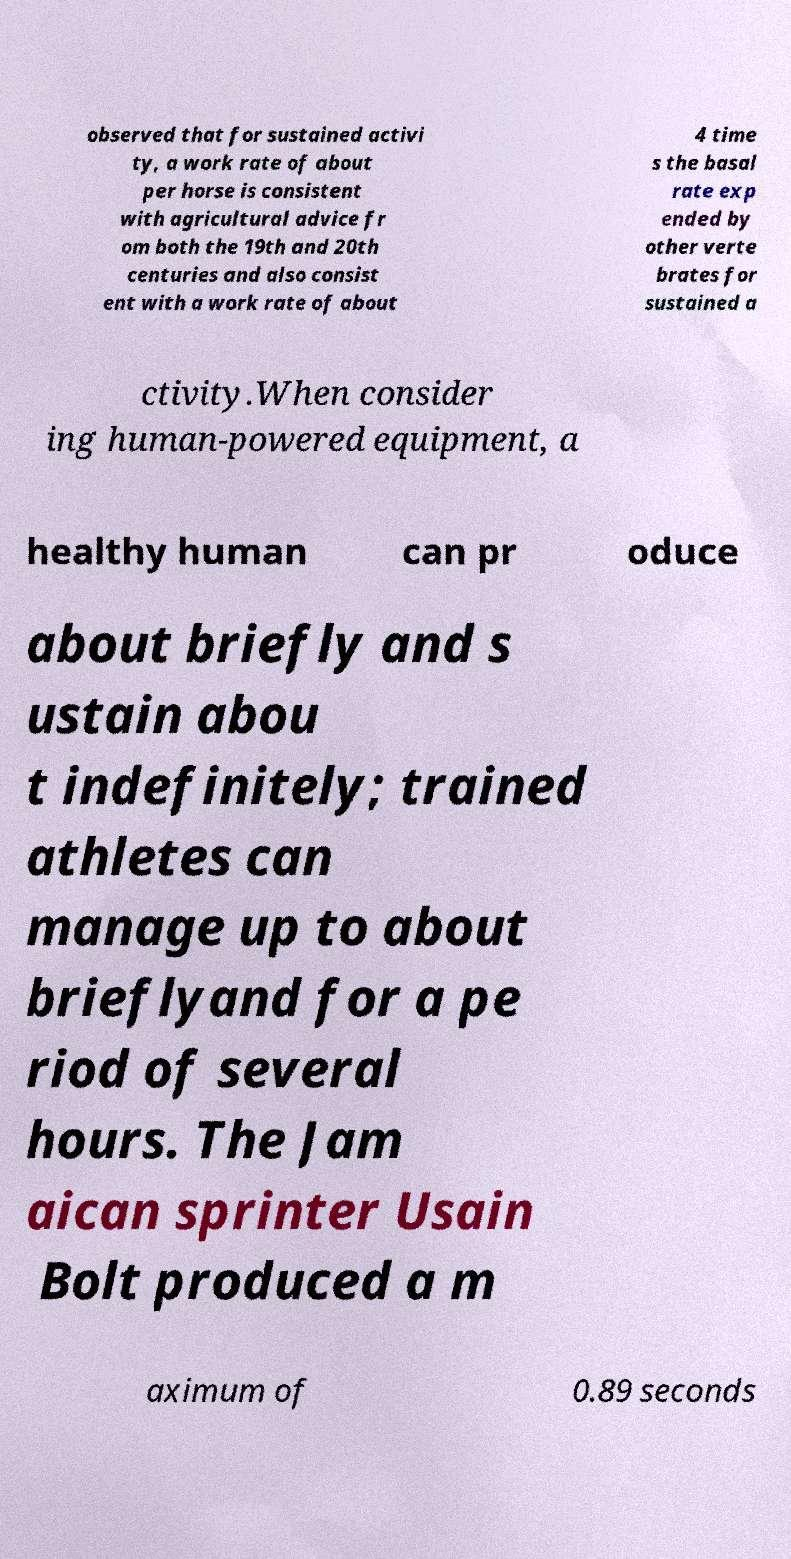Can you read and provide the text displayed in the image?This photo seems to have some interesting text. Can you extract and type it out for me? observed that for sustained activi ty, a work rate of about per horse is consistent with agricultural advice fr om both the 19th and 20th centuries and also consist ent with a work rate of about 4 time s the basal rate exp ended by other verte brates for sustained a ctivity.When consider ing human-powered equipment, a healthy human can pr oduce about briefly and s ustain abou t indefinitely; trained athletes can manage up to about brieflyand for a pe riod of several hours. The Jam aican sprinter Usain Bolt produced a m aximum of 0.89 seconds 